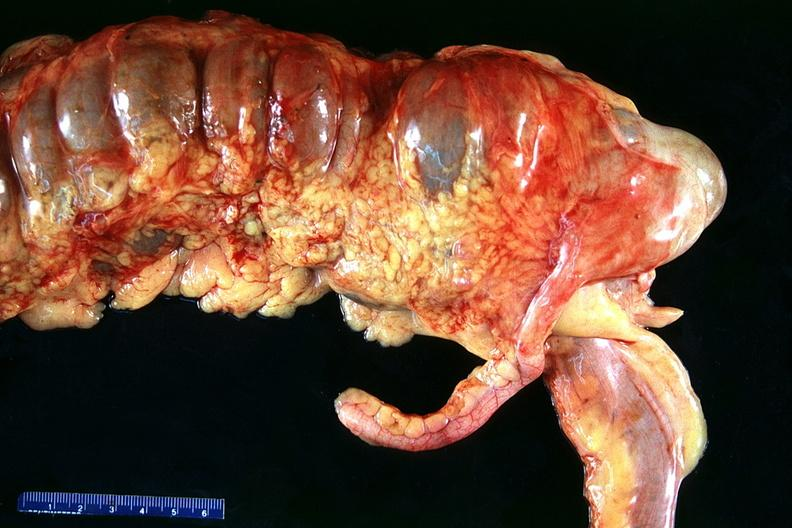what does this image show?
Answer the question using a single word or phrase. Normal appendix 